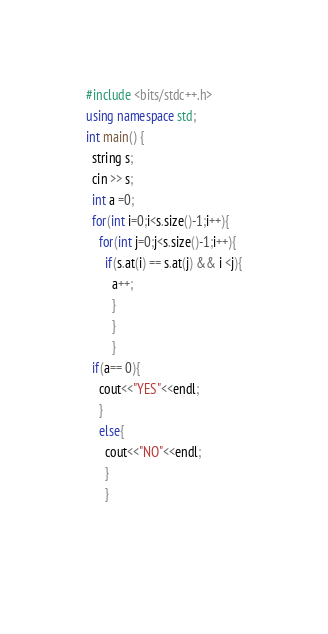Convert code to text. <code><loc_0><loc_0><loc_500><loc_500><_C++_>#include <bits/stdc++.h>
using namespace std;
int main() {
  string s;
  cin >> s;
  int a =0;
  for(int i=0;i<s.size()-1;i++){
    for(int j=0;j<s.size()-1;i++){
      if(s.at(i) == s.at(j) && i <j){
        a++;
        }
        }
        }
  if(a== 0){
    cout<<"YES"<<endl;
    }
    else{
      cout<<"NO"<<endl;
      }
      }
    
        </code> 